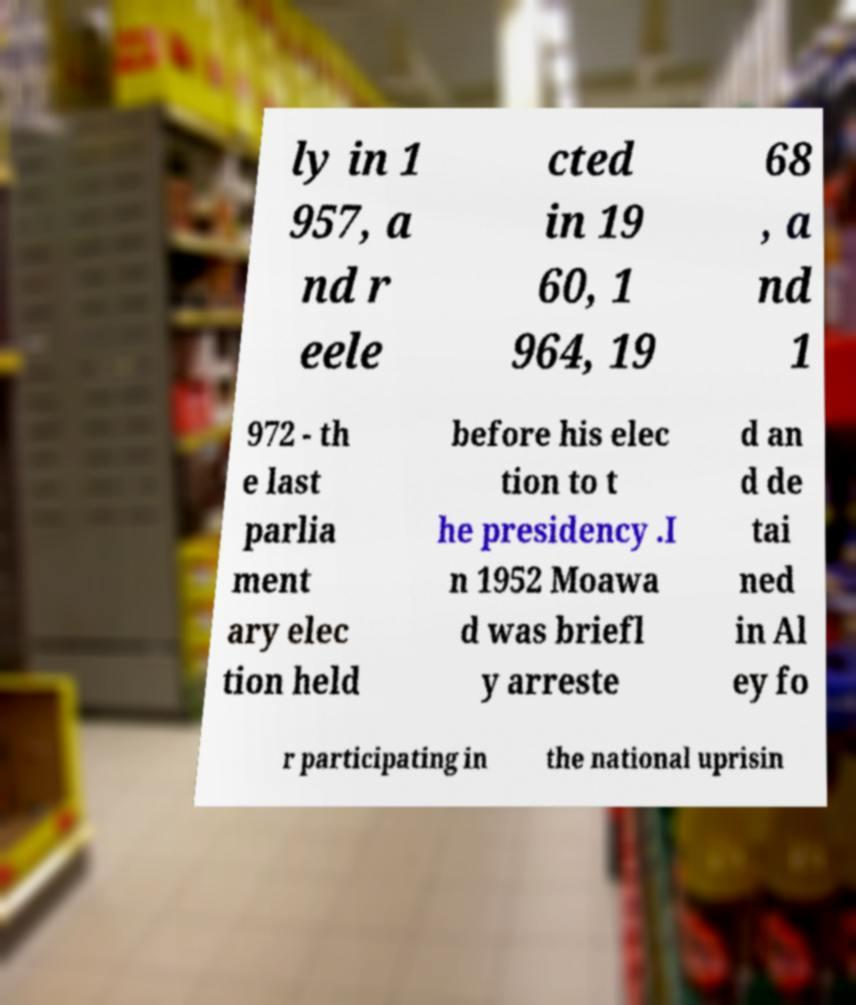Could you assist in decoding the text presented in this image and type it out clearly? ly in 1 957, a nd r eele cted in 19 60, 1 964, 19 68 , a nd 1 972 - th e last parlia ment ary elec tion held before his elec tion to t he presidency .I n 1952 Moawa d was briefl y arreste d an d de tai ned in Al ey fo r participating in the national uprisin 